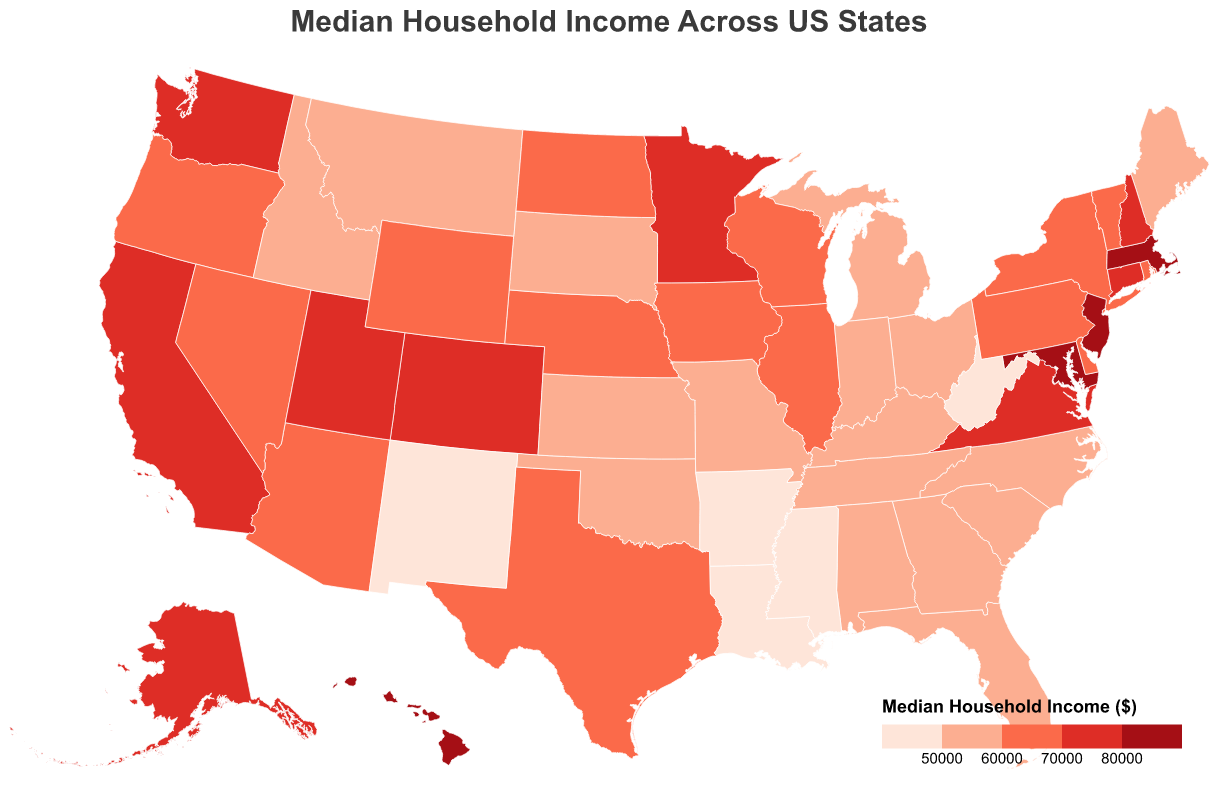What's the median household income in California? The tooltip and color shade for California on the map indicate the median household income value. Referring to the figure, California's median household income is $75,235.
Answer: $75,235 Which state has the highest median household income? By examining the darkest color shade and the tooltip, Maryland shows the highest value with a median income of $84,805.
Answer: Maryland Compare the median household incomes of Texas and Florida. Which state has a higher income? Looking at the map and comparing the tooltip values for Texas and Florida, Texas has a median income of $61,874, which is higher than Florida's $55,660.
Answer: Texas What is the range of median household incomes used in the color scale? The color scale shows thresholds of $50,000, $60,000, $70,000, and $80,000, which indicate the range.
Answer: $50,000 to $80,000 How many states have a median household income greater than $70,000? States with incomes greater than $70,000 will be shaded in the darkest colors. Counting these states from the map, we find six states: Maryland, New Jersey, Massachusetts, Alaska, Hawaii, and New Hampshire.
Answer: 6 Which state in the Midwest has the highest median household income? Midwest states include Illinois, Indiana, Iowa, Kansas, Michigan, Minnesota, Missouri, Nebraska, North Dakota, Ohio, South Dakota, and Wisconsin. Checking these states on the map, Minnesota has the highest with $71,306.
Answer: Minnesota What median household income value corresponds to the lightest shade of red on the map? The lightest shade of red represents the lowest income range in the color scale (> $45,000 and <= $50,000), focusing on states like Mississippi with an income of $45,081.
Answer: Between $45,000 and $50,000 Identify the states with a median household income less than $50,000. By checking the lightest colored states on the map, we identify Mississippi ($45,081), Louisiana ($49,469), and New Mexico ($49,754).
Answer: Mississippi, Louisiana, New Mexico What is the difference in median household income between Virginia and Pennsylvania? Virginia's median income is $74,222, and Pennsylvania's is $61,744. Subtracting these gives the difference: $74,222 - $61,744 = $12,478.
Answer: $12,478 What regions in the US, based on the map, tend to have higher household incomes? Examining the overall color shading across the map, the Northeast and coastal states appear darker, indicating higher median household incomes.
Answer: Northeast and coastal states 